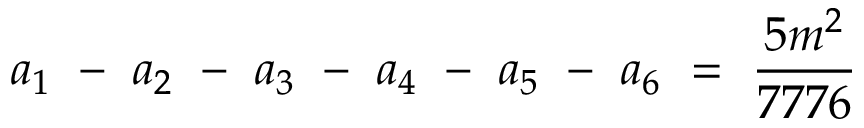<formula> <loc_0><loc_0><loc_500><loc_500>a _ { 1 } - a _ { 2 } - a _ { 3 } - a _ { 4 } - a _ { 5 } - a _ { 6 } = \frac { 5 m ^ { 2 } } { 7 7 7 6 }</formula> 